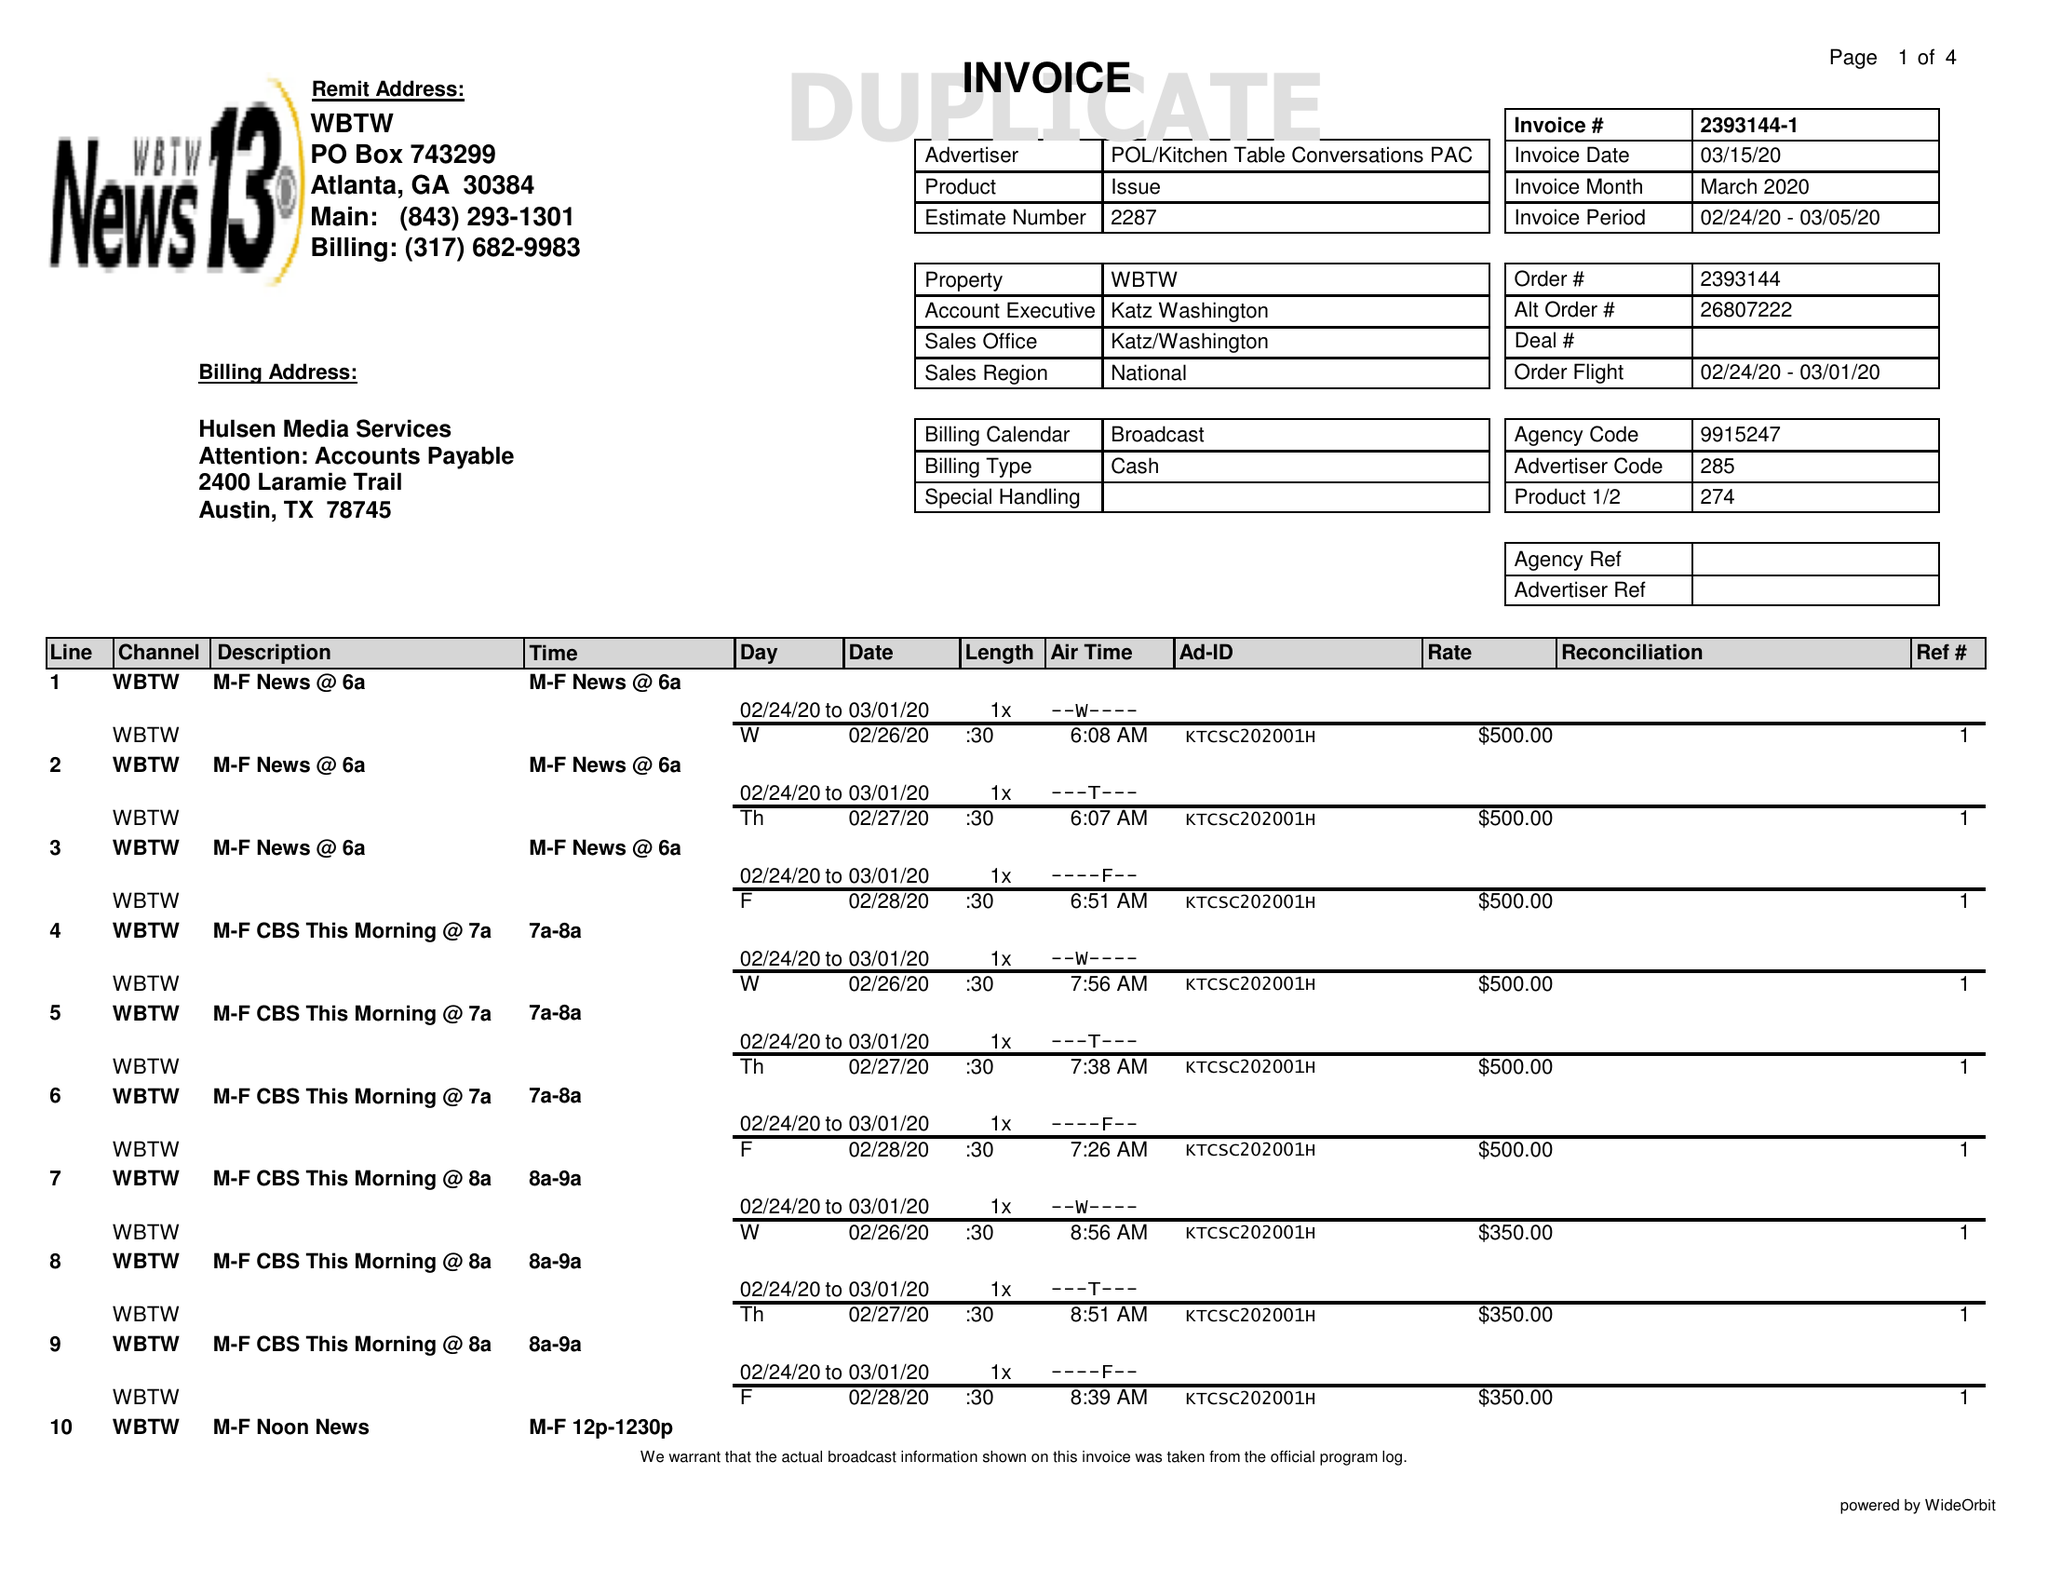What is the value for the advertiser?
Answer the question using a single word or phrase. POL/KITCHENTABLECONVERSATIONSPAC 